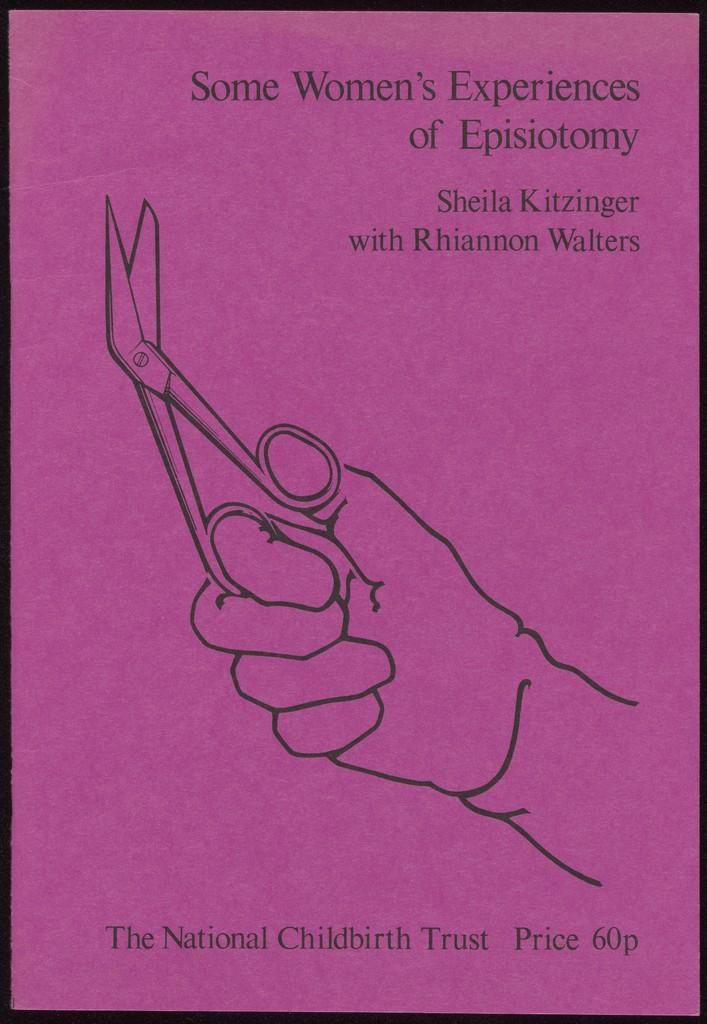Provide a one-sentence caption for the provided image. Poster showing a person holding a pair of scissors and the words "Some Women's experiences of Episiotomy". 